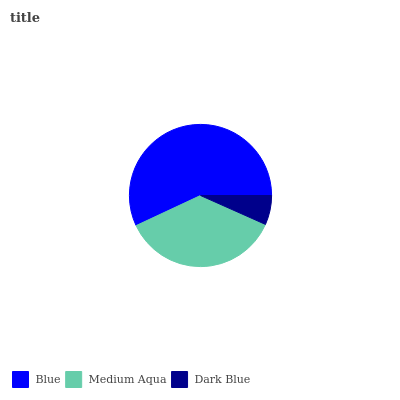Is Dark Blue the minimum?
Answer yes or no. Yes. Is Blue the maximum?
Answer yes or no. Yes. Is Medium Aqua the minimum?
Answer yes or no. No. Is Medium Aqua the maximum?
Answer yes or no. No. Is Blue greater than Medium Aqua?
Answer yes or no. Yes. Is Medium Aqua less than Blue?
Answer yes or no. Yes. Is Medium Aqua greater than Blue?
Answer yes or no. No. Is Blue less than Medium Aqua?
Answer yes or no. No. Is Medium Aqua the high median?
Answer yes or no. Yes. Is Medium Aqua the low median?
Answer yes or no. Yes. Is Dark Blue the high median?
Answer yes or no. No. Is Dark Blue the low median?
Answer yes or no. No. 